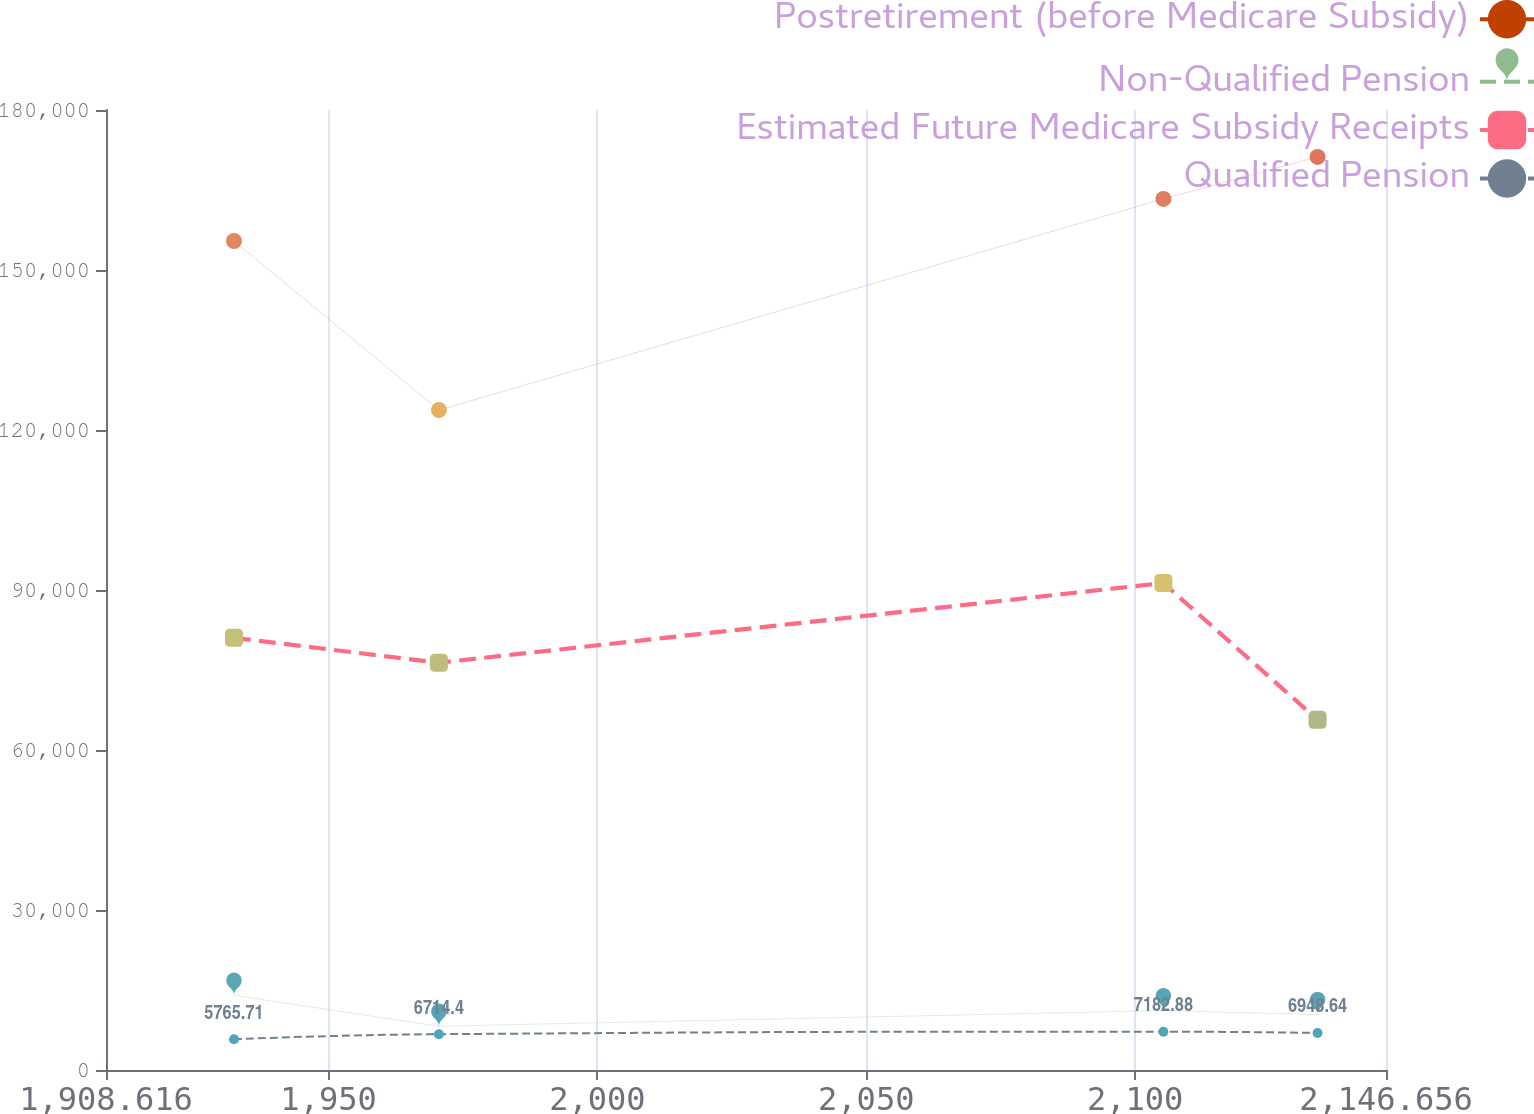Convert chart to OTSL. <chart><loc_0><loc_0><loc_500><loc_500><line_chart><ecel><fcel>Postretirement (before Medicare Subsidy)<fcel>Non-Qualified Pension<fcel>Estimated Future Medicare Subsidy Receipts<fcel>Qualified Pension<nl><fcel>1932.42<fcel>155440<fcel>14010.6<fcel>81037.9<fcel>5765.71<nl><fcel>1970.53<fcel>123728<fcel>8207.16<fcel>76360.1<fcel>6714.4<nl><fcel>2105.26<fcel>163324<fcel>11136.7<fcel>91311.7<fcel>7182.88<nl><fcel>2133.93<fcel>171209<fcel>10400.5<fcel>65672.9<fcel>6948.64<nl><fcel>2170.46<fcel>202573<fcel>15569.1<fcel>98776<fcel>8108.13<nl></chart> 